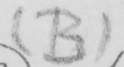Please provide the text content of this handwritten line. ( B ) 